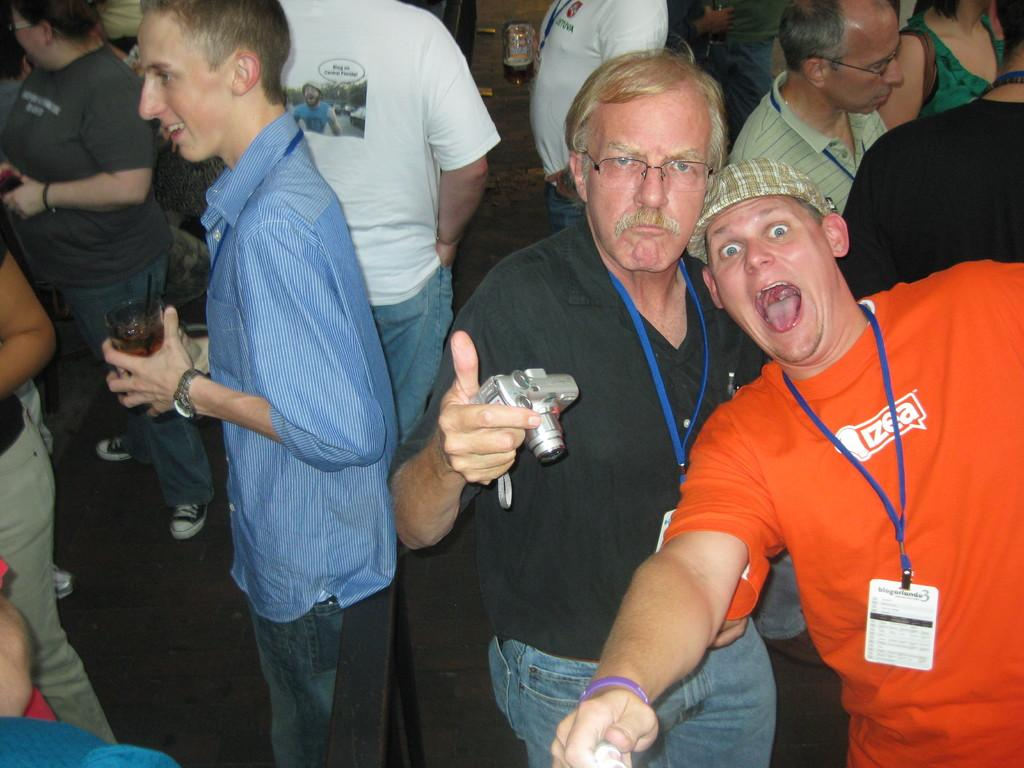What is the main subject of the image? The main subject of the image is a group of people. Can you describe the position of the man in the image? There is a man standing in the middle of the image. What is the man holding in the image? The man is holding a camera. What type of plane can be seen in the background of the image? There is no plane visible in the image. 